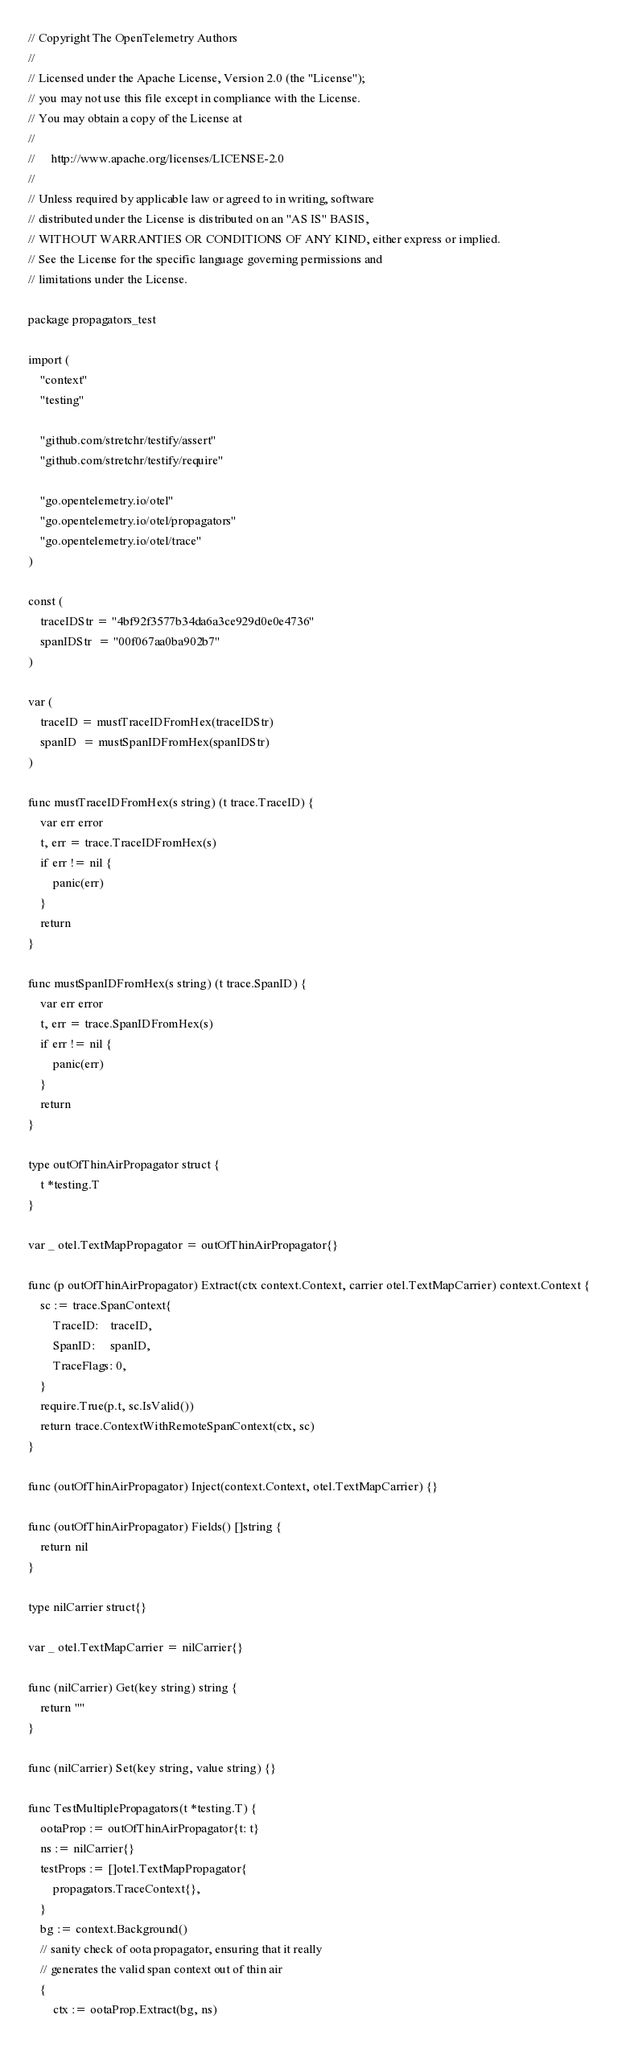<code> <loc_0><loc_0><loc_500><loc_500><_Go_>// Copyright The OpenTelemetry Authors
//
// Licensed under the Apache License, Version 2.0 (the "License");
// you may not use this file except in compliance with the License.
// You may obtain a copy of the License at
//
//     http://www.apache.org/licenses/LICENSE-2.0
//
// Unless required by applicable law or agreed to in writing, software
// distributed under the License is distributed on an "AS IS" BASIS,
// WITHOUT WARRANTIES OR CONDITIONS OF ANY KIND, either express or implied.
// See the License for the specific language governing permissions and
// limitations under the License.

package propagators_test

import (
	"context"
	"testing"

	"github.com/stretchr/testify/assert"
	"github.com/stretchr/testify/require"

	"go.opentelemetry.io/otel"
	"go.opentelemetry.io/otel/propagators"
	"go.opentelemetry.io/otel/trace"
)

const (
	traceIDStr = "4bf92f3577b34da6a3ce929d0e0e4736"
	spanIDStr  = "00f067aa0ba902b7"
)

var (
	traceID = mustTraceIDFromHex(traceIDStr)
	spanID  = mustSpanIDFromHex(spanIDStr)
)

func mustTraceIDFromHex(s string) (t trace.TraceID) {
	var err error
	t, err = trace.TraceIDFromHex(s)
	if err != nil {
		panic(err)
	}
	return
}

func mustSpanIDFromHex(s string) (t trace.SpanID) {
	var err error
	t, err = trace.SpanIDFromHex(s)
	if err != nil {
		panic(err)
	}
	return
}

type outOfThinAirPropagator struct {
	t *testing.T
}

var _ otel.TextMapPropagator = outOfThinAirPropagator{}

func (p outOfThinAirPropagator) Extract(ctx context.Context, carrier otel.TextMapCarrier) context.Context {
	sc := trace.SpanContext{
		TraceID:    traceID,
		SpanID:     spanID,
		TraceFlags: 0,
	}
	require.True(p.t, sc.IsValid())
	return trace.ContextWithRemoteSpanContext(ctx, sc)
}

func (outOfThinAirPropagator) Inject(context.Context, otel.TextMapCarrier) {}

func (outOfThinAirPropagator) Fields() []string {
	return nil
}

type nilCarrier struct{}

var _ otel.TextMapCarrier = nilCarrier{}

func (nilCarrier) Get(key string) string {
	return ""
}

func (nilCarrier) Set(key string, value string) {}

func TestMultiplePropagators(t *testing.T) {
	ootaProp := outOfThinAirPropagator{t: t}
	ns := nilCarrier{}
	testProps := []otel.TextMapPropagator{
		propagators.TraceContext{},
	}
	bg := context.Background()
	// sanity check of oota propagator, ensuring that it really
	// generates the valid span context out of thin air
	{
		ctx := ootaProp.Extract(bg, ns)</code> 